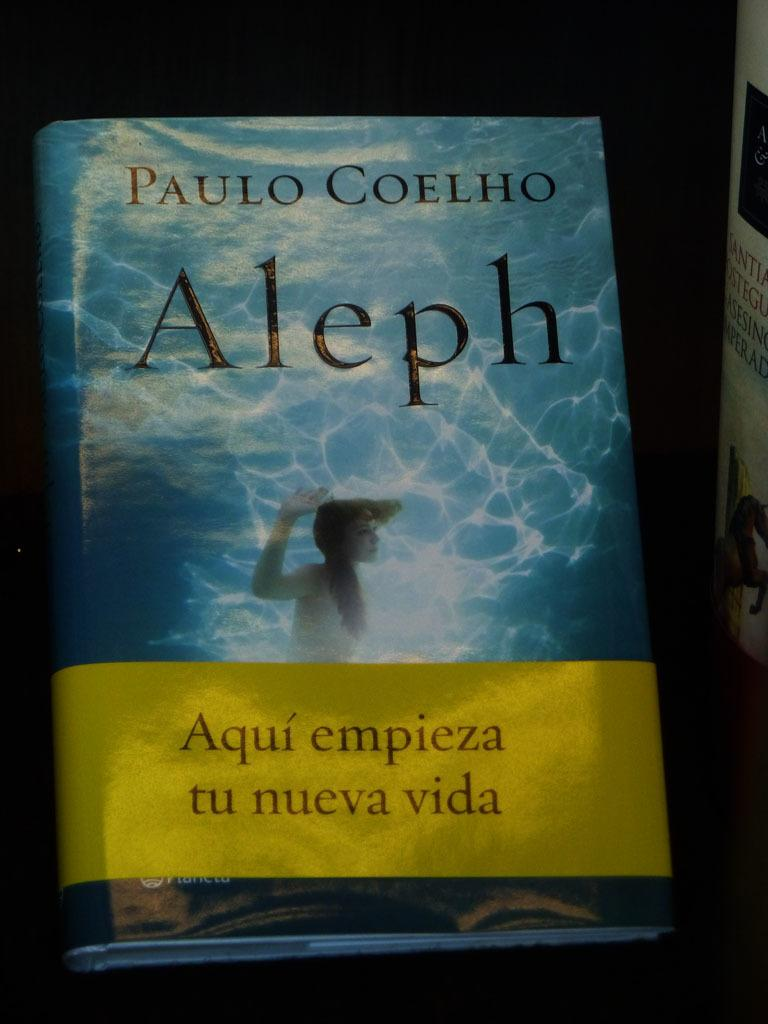<image>
Summarize the visual content of the image. Aleph book by author Paulo Coelho with a yellow Aqui empieza tu nueva vida sign. 